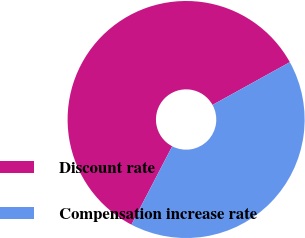<chart> <loc_0><loc_0><loc_500><loc_500><pie_chart><fcel>Discount rate<fcel>Compensation increase rate<nl><fcel>59.33%<fcel>40.67%<nl></chart> 